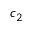<formula> <loc_0><loc_0><loc_500><loc_500>c _ { 2 }</formula> 